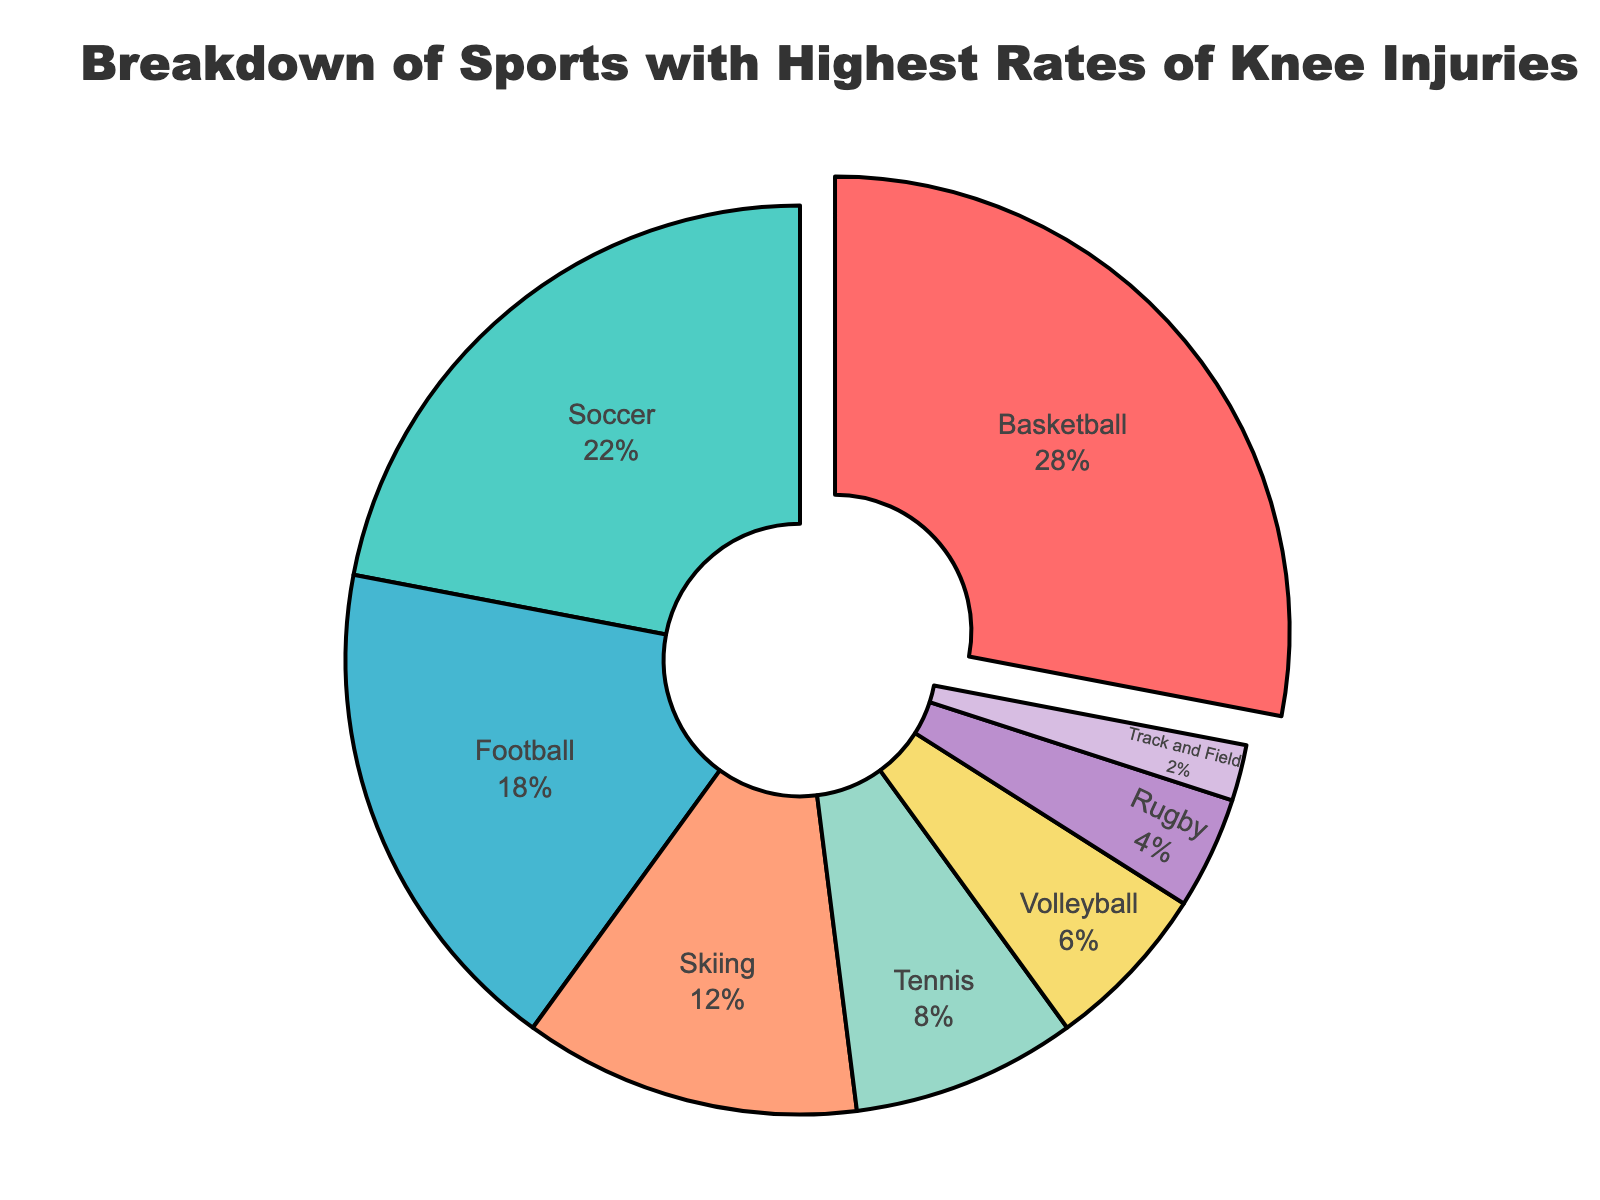What is the sport with the highest percentage of knee injuries? The figure shows the breakdown of sports with the highest rates of knee injuries using percentages. The sport with the largest section in the pie chart, labeled "28%", is Basketball.
Answer: Basketball What is the total percentage of knee injuries from Soccer and Football combined? To find the total percentage for Soccer and Football, add the percentages labeled for both: 22% (Soccer) + 18% (Football).
Answer: 40% Which sport has a greater percentage of knee injuries, Tennis or Volleyball? By comparing the sections of the pie chart labeled 8% and 6%, Tennis accounts for 8% while Volleyball accounts for 6%, showing Tennis has a greater percentage.
Answer: Tennis How much more likely are you to get a knee injury from Basketball than from Skiing? To determine this, compute the difference in their percentages: 28% (Basketball) - 12% (Skiing).
Answer: 16% Are knee injuries in Rugby more common than in Track and Field? By comparing the two percentages, Rugby (4%) and Track and Field (2%), Rugby has a higher percentage.
Answer: Yes What is the average percentage of knee injuries across all listed sports? Sum the percentages of all sports and divide by the number of sports. (28 + 22 + 18 + 12 + 8 + 6 + 4 + 2) / 8. First, compute the sum: 100. Dividing by 8, the average is 12.5%.
Answer: 12.5% List the sports in descending order of knee injury percentages. From the figure, order the sports by their labeled percentages: Basketball (28%), Soccer (22%), Football (18%), Skiing (12%), Tennis (8%), Volleyball (6%), Rugby (4%), Track and Field (2%).
Answer: Basketball, Soccer, Football, Skiing, Tennis, Volleyball, Rugby, Track and Field What percentage of knee injuries do the three least common sports account for? Add the percentages of the three smallest sections, which represent Rugby (4%), Volleyball (6%), and Track and Field (2%): 4% + 6% + 2%.
Answer: 12% By how much does the combined percentage of Volleyball and Rugby knee injuries differ from the percentage of Soccer knee injuries alone? Compute the combined percentage of Volleyball and Rugby: 6% + 4% = 10%. Then, find the difference compared to Soccer: 22% - 10%.
Answer: 12% 